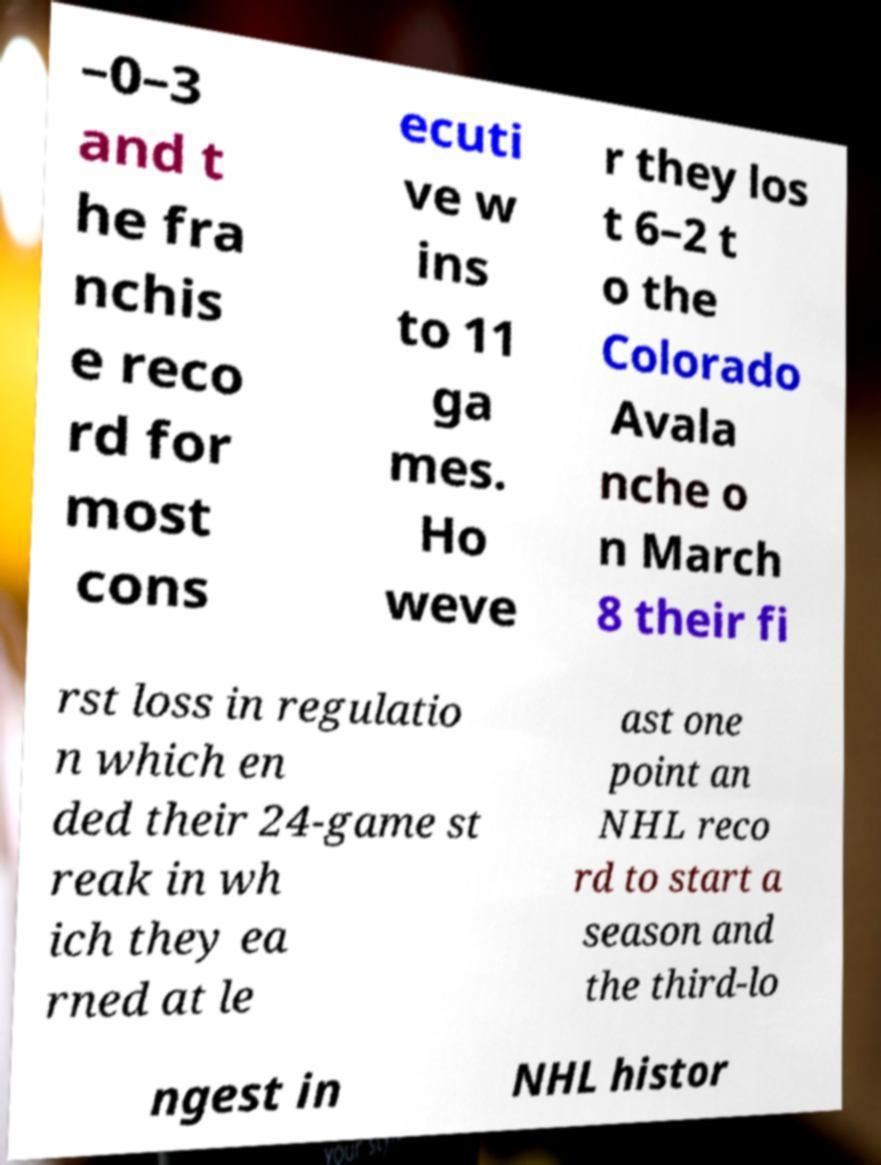Can you read and provide the text displayed in the image?This photo seems to have some interesting text. Can you extract and type it out for me? –0–3 and t he fra nchis e reco rd for most cons ecuti ve w ins to 11 ga mes. Ho weve r they los t 6–2 t o the Colorado Avala nche o n March 8 their fi rst loss in regulatio n which en ded their 24-game st reak in wh ich they ea rned at le ast one point an NHL reco rd to start a season and the third-lo ngest in NHL histor 